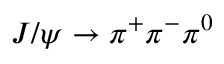Convert formula to latex. <formula><loc_0><loc_0><loc_500><loc_500>J / \psi \to \pi ^ { + } \pi ^ { - } \pi ^ { 0 }</formula> 